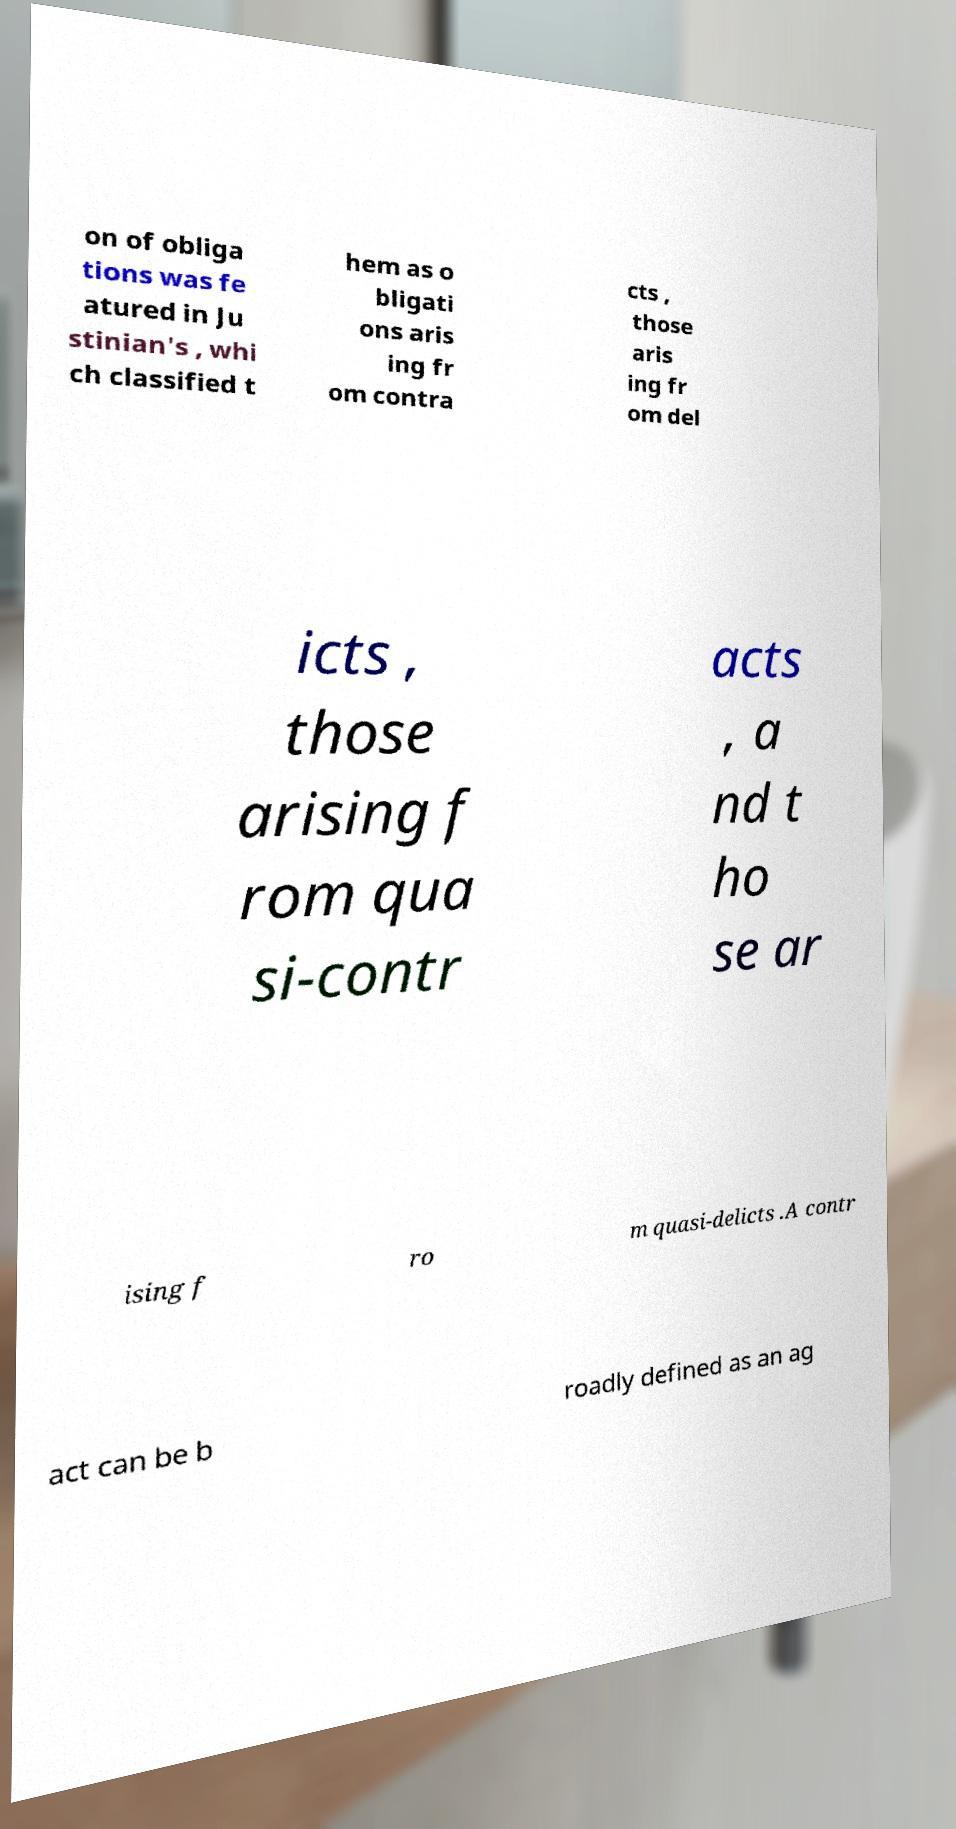I need the written content from this picture converted into text. Can you do that? on of obliga tions was fe atured in Ju stinian's , whi ch classified t hem as o bligati ons aris ing fr om contra cts , those aris ing fr om del icts , those arising f rom qua si-contr acts , a nd t ho se ar ising f ro m quasi-delicts .A contr act can be b roadly defined as an ag 